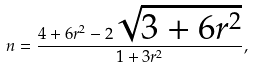<formula> <loc_0><loc_0><loc_500><loc_500>n = \frac { 4 + 6 r ^ { 2 } - 2 \sqrt { 3 + 6 r ^ { 2 } } } { 1 + 3 r ^ { 2 } } ,</formula> 